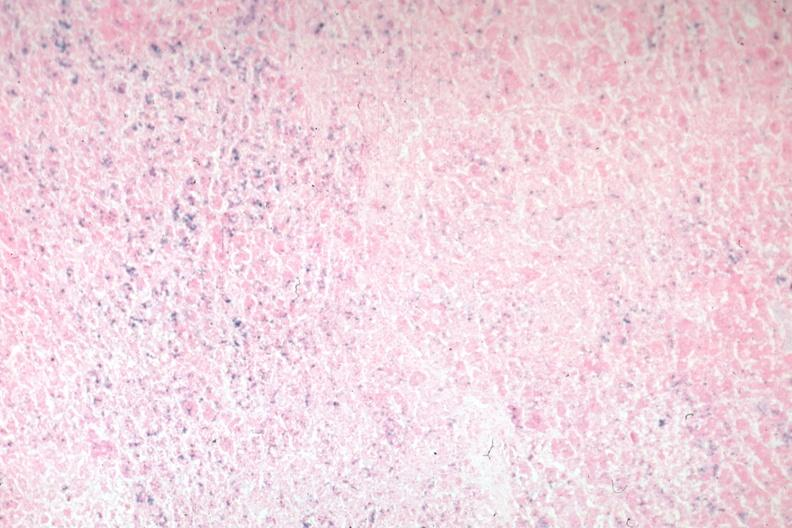s endocrine present?
Answer the question using a single word or phrase. Yes 